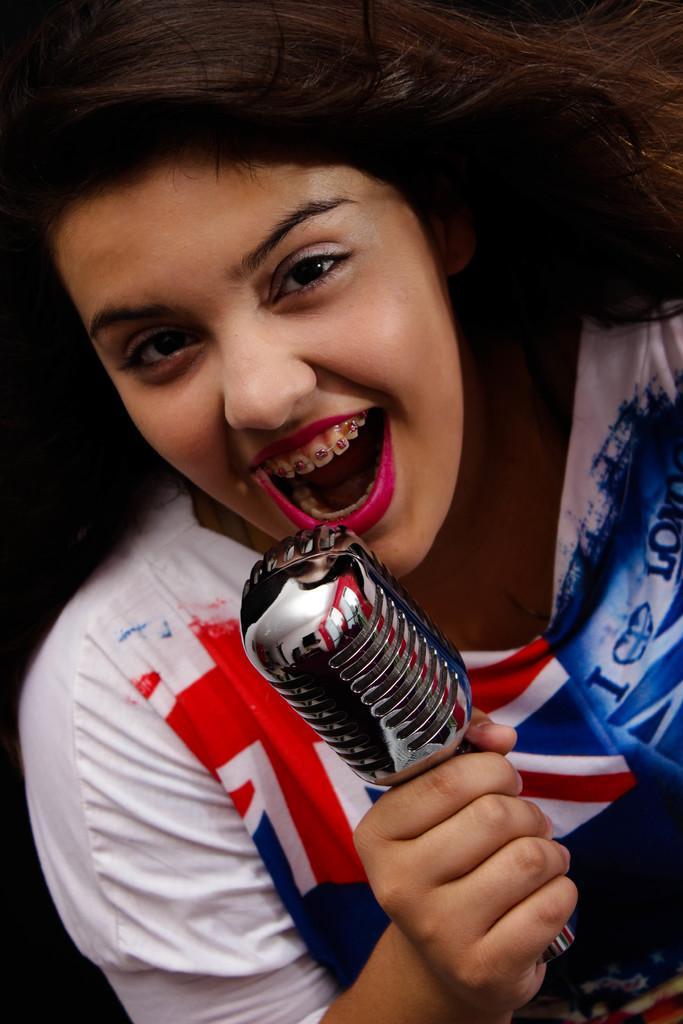How would you summarize this image in a sentence or two? Here we can see a woman holding a microphone and she is probably singing and this we can say by seeing her mouth 